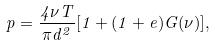Convert formula to latex. <formula><loc_0><loc_0><loc_500><loc_500>p = \frac { 4 \nu T } { \pi d ^ { 2 } } [ 1 + ( 1 + e ) G ( \nu ) ] ,</formula> 